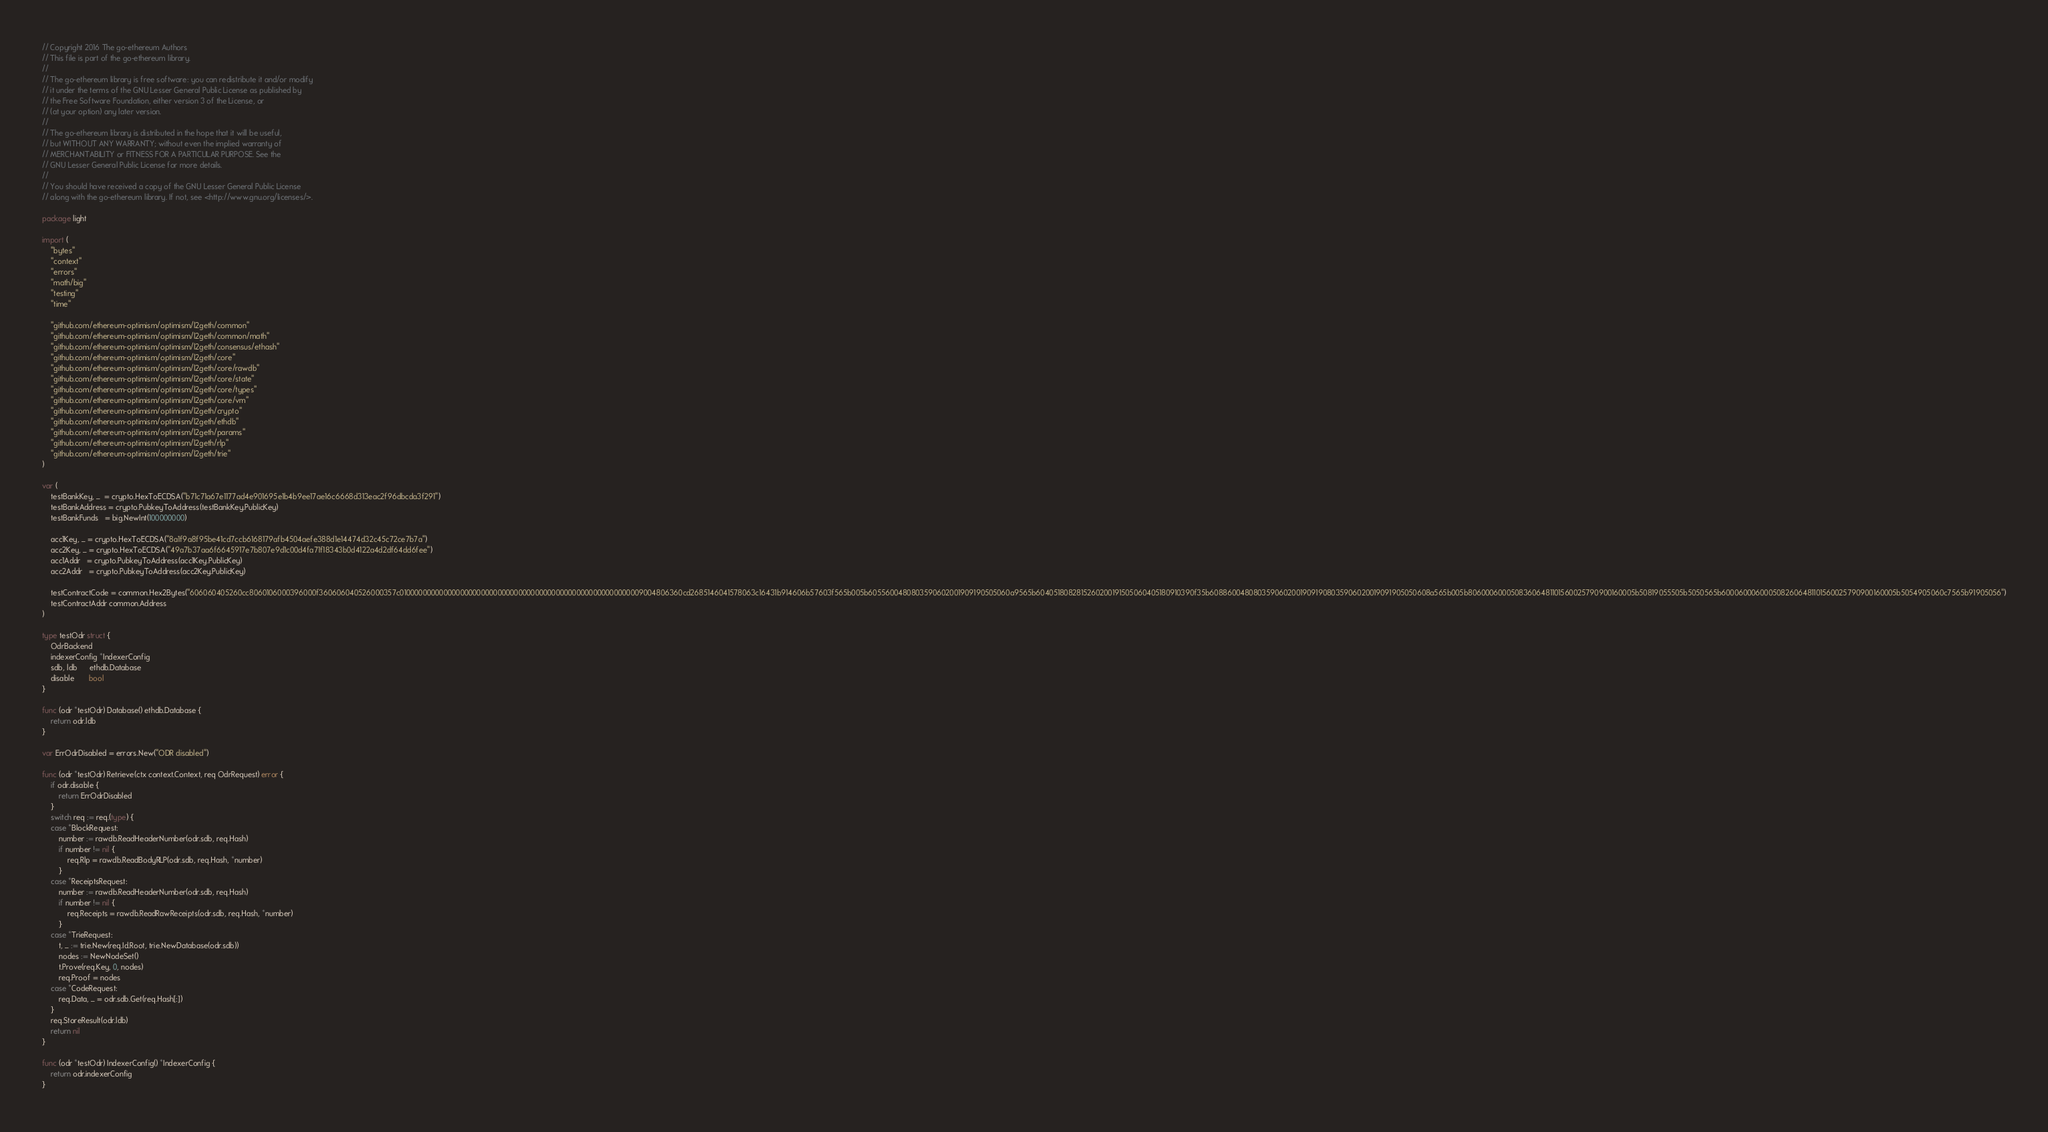Convert code to text. <code><loc_0><loc_0><loc_500><loc_500><_Go_>// Copyright 2016 The go-ethereum Authors
// This file is part of the go-ethereum library.
//
// The go-ethereum library is free software: you can redistribute it and/or modify
// it under the terms of the GNU Lesser General Public License as published by
// the Free Software Foundation, either version 3 of the License, or
// (at your option) any later version.
//
// The go-ethereum library is distributed in the hope that it will be useful,
// but WITHOUT ANY WARRANTY; without even the implied warranty of
// MERCHANTABILITY or FITNESS FOR A PARTICULAR PURPOSE. See the
// GNU Lesser General Public License for more details.
//
// You should have received a copy of the GNU Lesser General Public License
// along with the go-ethereum library. If not, see <http://www.gnu.org/licenses/>.

package light

import (
	"bytes"
	"context"
	"errors"
	"math/big"
	"testing"
	"time"

	"github.com/ethereum-optimism/optimism/l2geth/common"
	"github.com/ethereum-optimism/optimism/l2geth/common/math"
	"github.com/ethereum-optimism/optimism/l2geth/consensus/ethash"
	"github.com/ethereum-optimism/optimism/l2geth/core"
	"github.com/ethereum-optimism/optimism/l2geth/core/rawdb"
	"github.com/ethereum-optimism/optimism/l2geth/core/state"
	"github.com/ethereum-optimism/optimism/l2geth/core/types"
	"github.com/ethereum-optimism/optimism/l2geth/core/vm"
	"github.com/ethereum-optimism/optimism/l2geth/crypto"
	"github.com/ethereum-optimism/optimism/l2geth/ethdb"
	"github.com/ethereum-optimism/optimism/l2geth/params"
	"github.com/ethereum-optimism/optimism/l2geth/rlp"
	"github.com/ethereum-optimism/optimism/l2geth/trie"
)

var (
	testBankKey, _  = crypto.HexToECDSA("b71c71a67e1177ad4e901695e1b4b9ee17ae16c6668d313eac2f96dbcda3f291")
	testBankAddress = crypto.PubkeyToAddress(testBankKey.PublicKey)
	testBankFunds   = big.NewInt(100000000)

	acc1Key, _ = crypto.HexToECDSA("8a1f9a8f95be41cd7ccb6168179afb4504aefe388d1e14474d32c45c72ce7b7a")
	acc2Key, _ = crypto.HexToECDSA("49a7b37aa6f6645917e7b807e9d1c00d4fa71f18343b0d4122a4d2df64dd6fee")
	acc1Addr   = crypto.PubkeyToAddress(acc1Key.PublicKey)
	acc2Addr   = crypto.PubkeyToAddress(acc2Key.PublicKey)

	testContractCode = common.Hex2Bytes("606060405260cc8060106000396000f360606040526000357c01000000000000000000000000000000000000000000000000000000009004806360cd2685146041578063c16431b914606b57603f565b005b6055600480803590602001909190505060a9565b6040518082815260200191505060405180910390f35b60886004808035906020019091908035906020019091905050608a565b005b80600060005083606481101560025790900160005b50819055505b5050565b6000600060005082606481101560025790900160005b5054905060c7565b91905056")
	testContractAddr common.Address
)

type testOdr struct {
	OdrBackend
	indexerConfig *IndexerConfig
	sdb, ldb      ethdb.Database
	disable       bool
}

func (odr *testOdr) Database() ethdb.Database {
	return odr.ldb
}

var ErrOdrDisabled = errors.New("ODR disabled")

func (odr *testOdr) Retrieve(ctx context.Context, req OdrRequest) error {
	if odr.disable {
		return ErrOdrDisabled
	}
	switch req := req.(type) {
	case *BlockRequest:
		number := rawdb.ReadHeaderNumber(odr.sdb, req.Hash)
		if number != nil {
			req.Rlp = rawdb.ReadBodyRLP(odr.sdb, req.Hash, *number)
		}
	case *ReceiptsRequest:
		number := rawdb.ReadHeaderNumber(odr.sdb, req.Hash)
		if number != nil {
			req.Receipts = rawdb.ReadRawReceipts(odr.sdb, req.Hash, *number)
		}
	case *TrieRequest:
		t, _ := trie.New(req.Id.Root, trie.NewDatabase(odr.sdb))
		nodes := NewNodeSet()
		t.Prove(req.Key, 0, nodes)
		req.Proof = nodes
	case *CodeRequest:
		req.Data, _ = odr.sdb.Get(req.Hash[:])
	}
	req.StoreResult(odr.ldb)
	return nil
}

func (odr *testOdr) IndexerConfig() *IndexerConfig {
	return odr.indexerConfig
}
</code> 